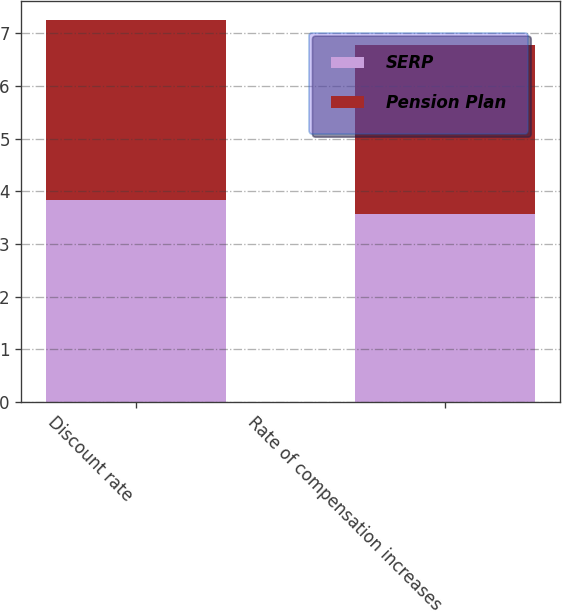<chart> <loc_0><loc_0><loc_500><loc_500><stacked_bar_chart><ecel><fcel>Discount rate<fcel>Rate of compensation increases<nl><fcel>SERP<fcel>3.84<fcel>3.57<nl><fcel>Pension Plan<fcel>3.41<fcel>3.21<nl></chart> 